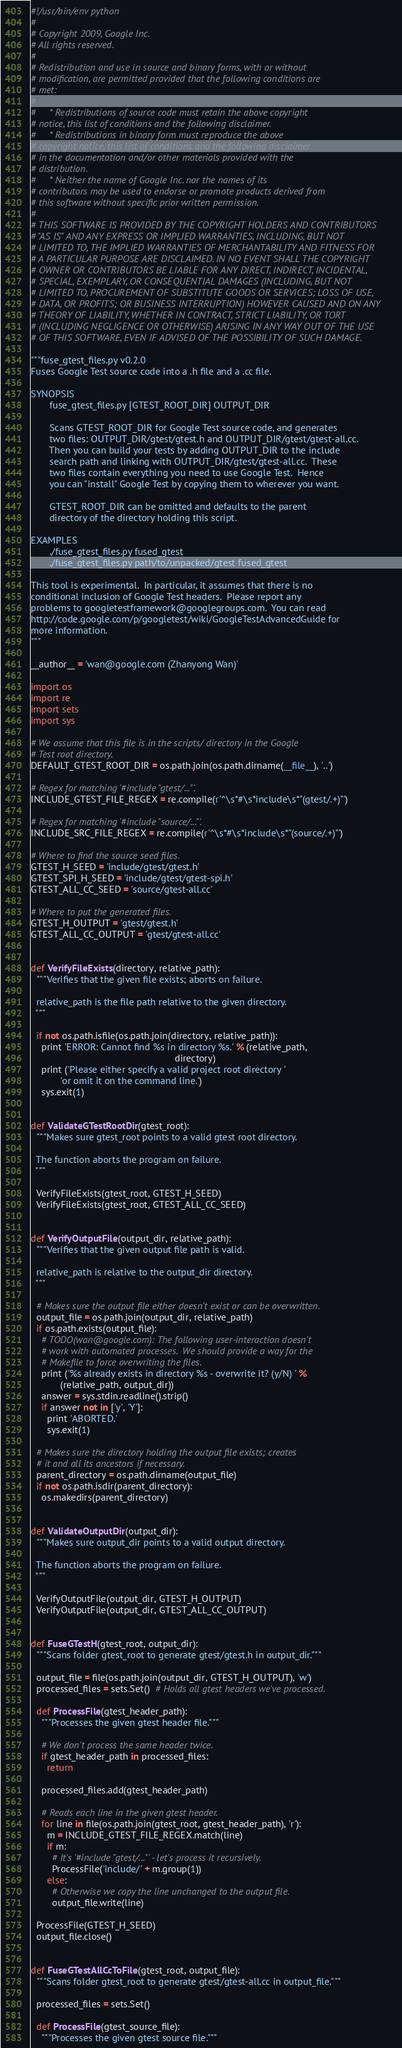<code> <loc_0><loc_0><loc_500><loc_500><_Python_>#!/usr/bin/env python
#
# Copyright 2009, Google Inc.
# All rights reserved.
#
# Redistribution and use in source and binary forms, with or without
# modification, are permitted provided that the following conditions are
# met:
#
#     * Redistributions of source code must retain the above copyright
# notice, this list of conditions and the following disclaimer.
#     * Redistributions in binary form must reproduce the above
# copyright notice, this list of conditions and the following disclaimer
# in the documentation and/or other materials provided with the
# distribution.
#     * Neither the name of Google Inc. nor the names of its
# contributors may be used to endorse or promote products derived from
# this software without specific prior written permission.
#
# THIS SOFTWARE IS PROVIDED BY THE COPYRIGHT HOLDERS AND CONTRIBUTORS
# "AS IS" AND ANY EXPRESS OR IMPLIED WARRANTIES, INCLUDING, BUT NOT
# LIMITED TO, THE IMPLIED WARRANTIES OF MERCHANTABILITY AND FITNESS FOR
# A PARTICULAR PURPOSE ARE DISCLAIMED. IN NO EVENT SHALL THE COPYRIGHT
# OWNER OR CONTRIBUTORS BE LIABLE FOR ANY DIRECT, INDIRECT, INCIDENTAL,
# SPECIAL, EXEMPLARY, OR CONSEQUENTIAL DAMAGES (INCLUDING, BUT NOT
# LIMITED TO, PROCUREMENT OF SUBSTITUTE GOODS OR SERVICES; LOSS OF USE,
# DATA, OR PROFITS; OR BUSINESS INTERRUPTION) HOWEVER CAUSED AND ON ANY
# THEORY OF LIABILITY, WHETHER IN CONTRACT, STRICT LIABILITY, OR TORT
# (INCLUDING NEGLIGENCE OR OTHERWISE) ARISING IN ANY WAY OUT OF THE USE
# OF THIS SOFTWARE, EVEN IF ADVISED OF THE POSSIBILITY OF SUCH DAMAGE.

"""fuse_gtest_files.py v0.2.0
Fuses Google Test source code into a .h file and a .cc file.

SYNOPSIS
       fuse_gtest_files.py [GTEST_ROOT_DIR] OUTPUT_DIR

       Scans GTEST_ROOT_DIR for Google Test source code, and generates
       two files: OUTPUT_DIR/gtest/gtest.h and OUTPUT_DIR/gtest/gtest-all.cc.
       Then you can build your tests by adding OUTPUT_DIR to the include
       search path and linking with OUTPUT_DIR/gtest/gtest-all.cc.  These
       two files contain everything you need to use Google Test.  Hence
       you can "install" Google Test by copying them to wherever you want.

       GTEST_ROOT_DIR can be omitted and defaults to the parent
       directory of the directory holding this script.

EXAMPLES
       ./fuse_gtest_files.py fused_gtest
       ./fuse_gtest_files.py path/to/unpacked/gtest fused_gtest

This tool is experimental.  In particular, it assumes that there is no
conditional inclusion of Google Test headers.  Please report any
problems to googletestframework@googlegroups.com.  You can read
http://code.google.com/p/googletest/wiki/GoogleTestAdvancedGuide for
more information.
"""

__author__ = 'wan@google.com (Zhanyong Wan)'

import os
import re
import sets
import sys

# We assume that this file is in the scripts/ directory in the Google
# Test root directory.
DEFAULT_GTEST_ROOT_DIR = os.path.join(os.path.dirname(__file__), '..')

# Regex for matching '#include "gtest/..."'.
INCLUDE_GTEST_FILE_REGEX = re.compile(r'^\s*#\s*include\s*"(gtest/.+)"')

# Regex for matching '#include "source/..."'.
INCLUDE_SRC_FILE_REGEX = re.compile(r'^\s*#\s*include\s*"(source/.+)"')

# Where to find the source seed files.
GTEST_H_SEED = 'include/gtest/gtest.h'
GTEST_SPI_H_SEED = 'include/gtest/gtest-spi.h'
GTEST_ALL_CC_SEED = 'source/gtest-all.cc'

# Where to put the generated files.
GTEST_H_OUTPUT = 'gtest/gtest.h'
GTEST_ALL_CC_OUTPUT = 'gtest/gtest-all.cc'


def VerifyFileExists(directory, relative_path):
  """Verifies that the given file exists; aborts on failure.

  relative_path is the file path relative to the given directory.
  """

  if not os.path.isfile(os.path.join(directory, relative_path)):
    print 'ERROR: Cannot find %s in directory %s.' % (relative_path,
                                                      directory)
    print ('Please either specify a valid project root directory '
           'or omit it on the command line.')
    sys.exit(1)


def ValidateGTestRootDir(gtest_root):
  """Makes sure gtest_root points to a valid gtest root directory.

  The function aborts the program on failure.
  """

  VerifyFileExists(gtest_root, GTEST_H_SEED)
  VerifyFileExists(gtest_root, GTEST_ALL_CC_SEED)


def VerifyOutputFile(output_dir, relative_path):
  """Verifies that the given output file path is valid.

  relative_path is relative to the output_dir directory.
  """

  # Makes sure the output file either doesn't exist or can be overwritten.
  output_file = os.path.join(output_dir, relative_path)
  if os.path.exists(output_file):
    # TODO(wan@google.com): The following user-interaction doesn't
    # work with automated processes.  We should provide a way for the
    # Makefile to force overwriting the files.
    print ('%s already exists in directory %s - overwrite it? (y/N) ' %
           (relative_path, output_dir))
    answer = sys.stdin.readline().strip()
    if answer not in ['y', 'Y']:
      print 'ABORTED.'
      sys.exit(1)

  # Makes sure the directory holding the output file exists; creates
  # it and all its ancestors if necessary.
  parent_directory = os.path.dirname(output_file)
  if not os.path.isdir(parent_directory):
    os.makedirs(parent_directory)


def ValidateOutputDir(output_dir):
  """Makes sure output_dir points to a valid output directory.

  The function aborts the program on failure.
  """

  VerifyOutputFile(output_dir, GTEST_H_OUTPUT)
  VerifyOutputFile(output_dir, GTEST_ALL_CC_OUTPUT)


def FuseGTestH(gtest_root, output_dir):
  """Scans folder gtest_root to generate gtest/gtest.h in output_dir."""

  output_file = file(os.path.join(output_dir, GTEST_H_OUTPUT), 'w')
  processed_files = sets.Set()  # Holds all gtest headers we've processed.

  def ProcessFile(gtest_header_path):
    """Processes the given gtest header file."""

    # We don't process the same header twice.
    if gtest_header_path in processed_files:
      return

    processed_files.add(gtest_header_path)

    # Reads each line in the given gtest header.
    for line in file(os.path.join(gtest_root, gtest_header_path), 'r'):
      m = INCLUDE_GTEST_FILE_REGEX.match(line)
      if m:
        # It's '#include "gtest/..."' - let's process it recursively.
        ProcessFile('include/' + m.group(1))
      else:
        # Otherwise we copy the line unchanged to the output file.
        output_file.write(line)

  ProcessFile(GTEST_H_SEED)
  output_file.close()


def FuseGTestAllCcToFile(gtest_root, output_file):
  """Scans folder gtest_root to generate gtest/gtest-all.cc in output_file."""

  processed_files = sets.Set()

  def ProcessFile(gtest_source_file):
    """Processes the given gtest source file."""
</code> 